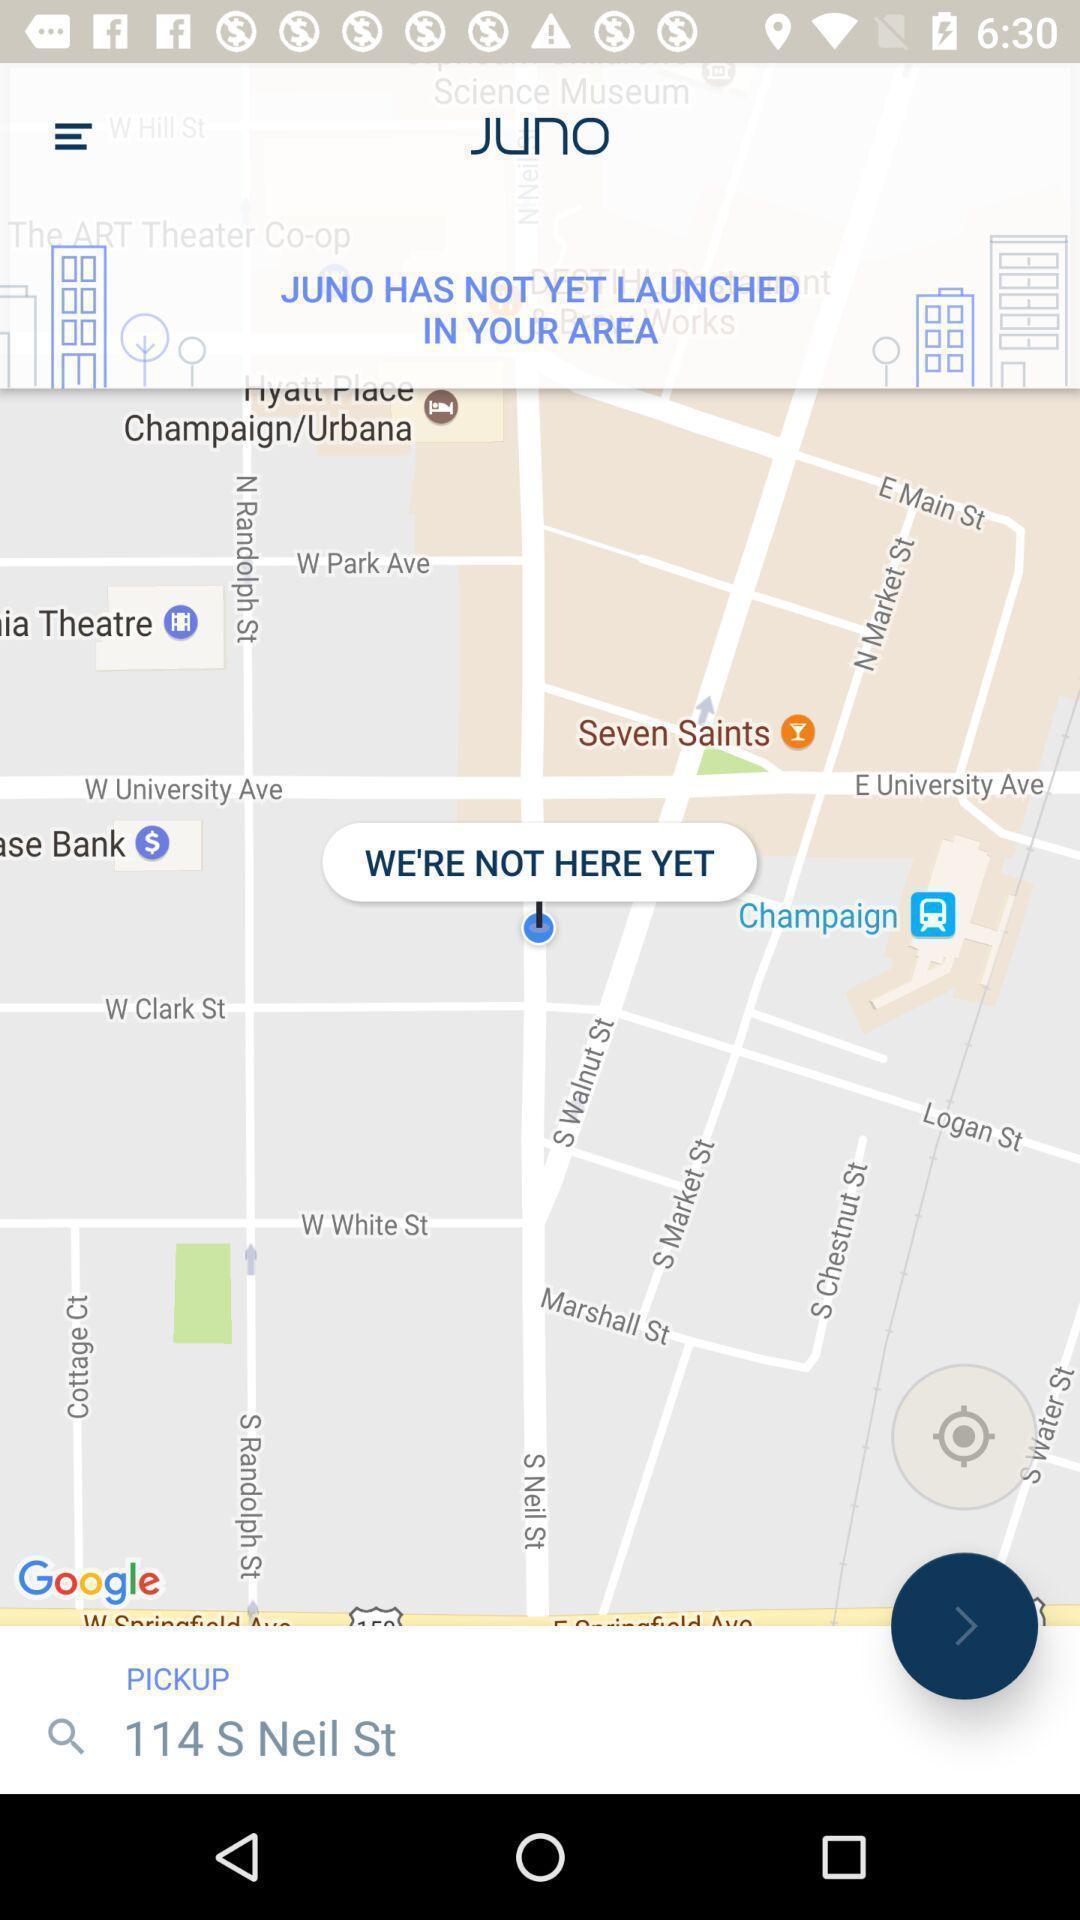Explain what's happening in this screen capture. Page shows information about the navigation app. 